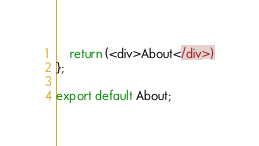Convert code to text. <code><loc_0><loc_0><loc_500><loc_500><_TypeScript_>    return (<div>About</div>)
};

export default About;
</code> 